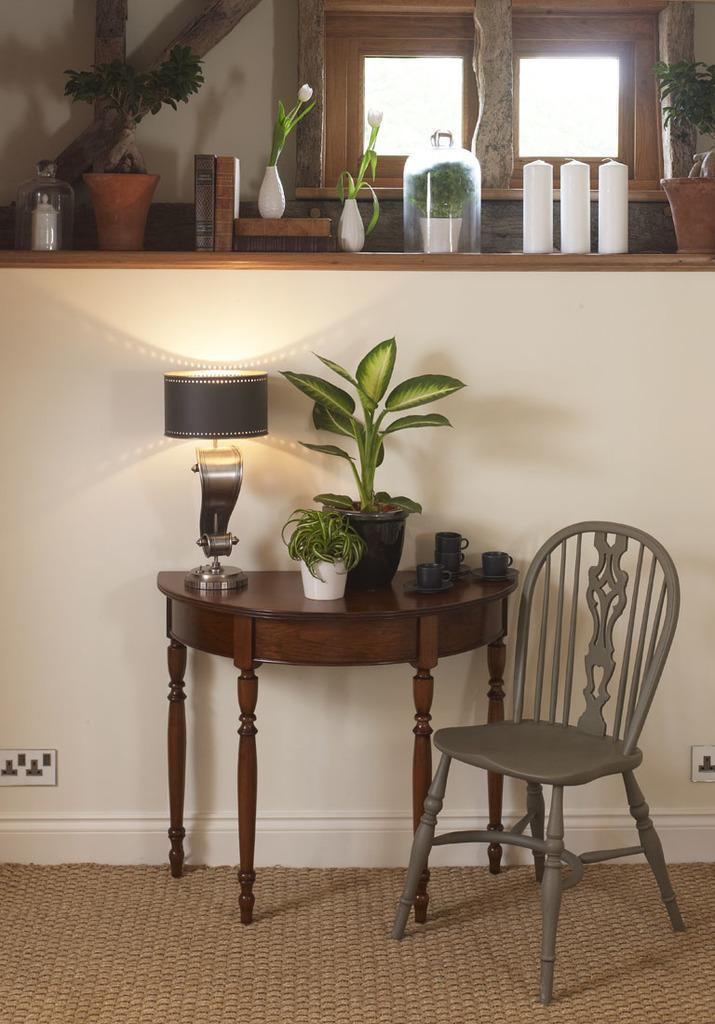In one or two sentences, can you explain what this image depicts? The photo is taken inside a room. There is a table and a chair. On the table there is a lamp ,two plant pot and cups and plates. Beside it there is a wall on it there are jars,pot,candles. In the background there is a window. On the floor has a carpet. 